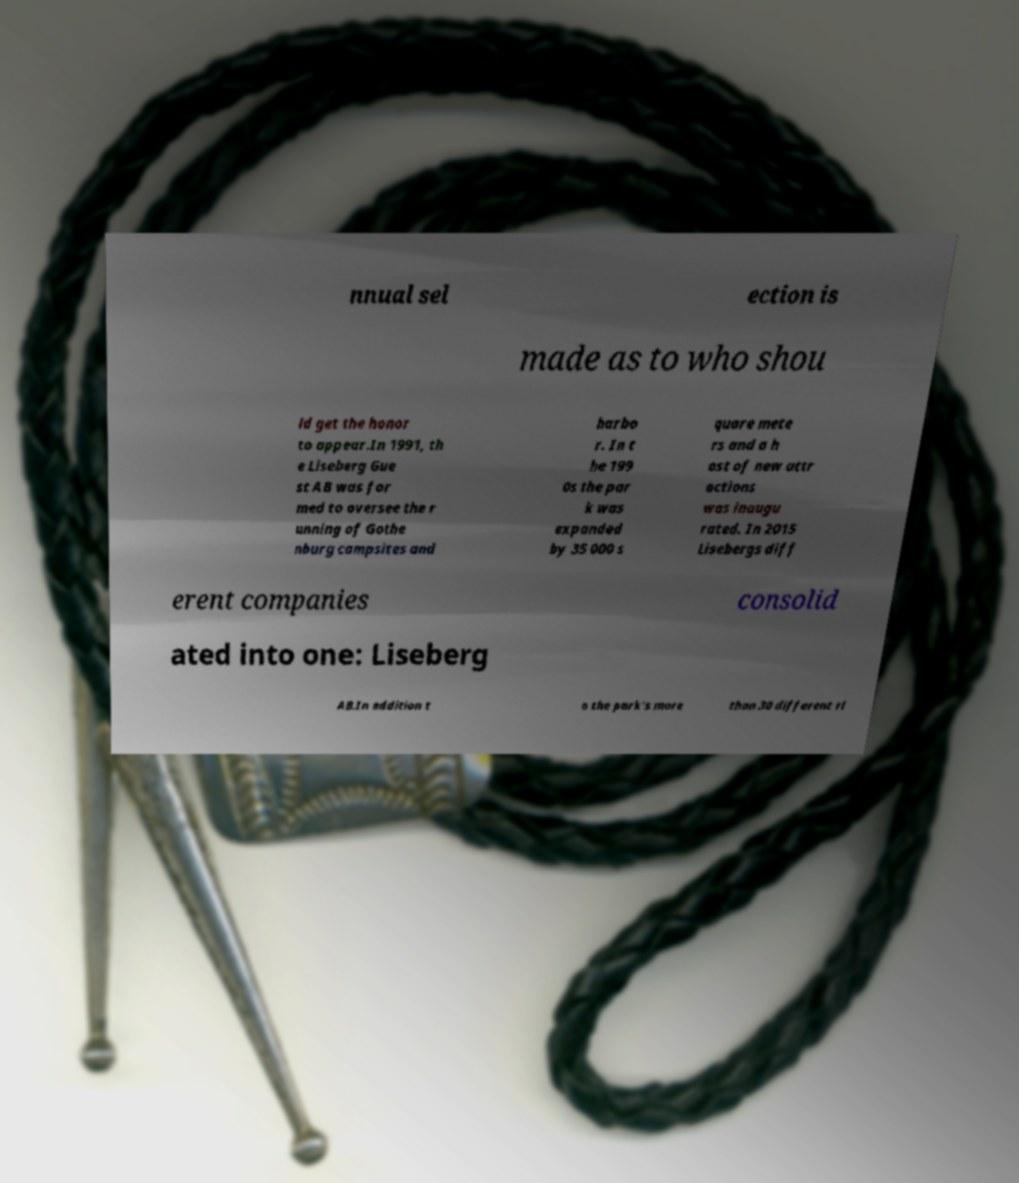Could you assist in decoding the text presented in this image and type it out clearly? nnual sel ection is made as to who shou ld get the honor to appear.In 1991, th e Liseberg Gue st AB was for med to oversee the r unning of Gothe nburg campsites and harbo r. In t he 199 0s the par k was expanded by 35 000 s quare mete rs and a h ost of new attr actions was inaugu rated. In 2015 Lisebergs diff erent companies consolid ated into one: Liseberg AB.In addition t o the park's more than 30 different ri 